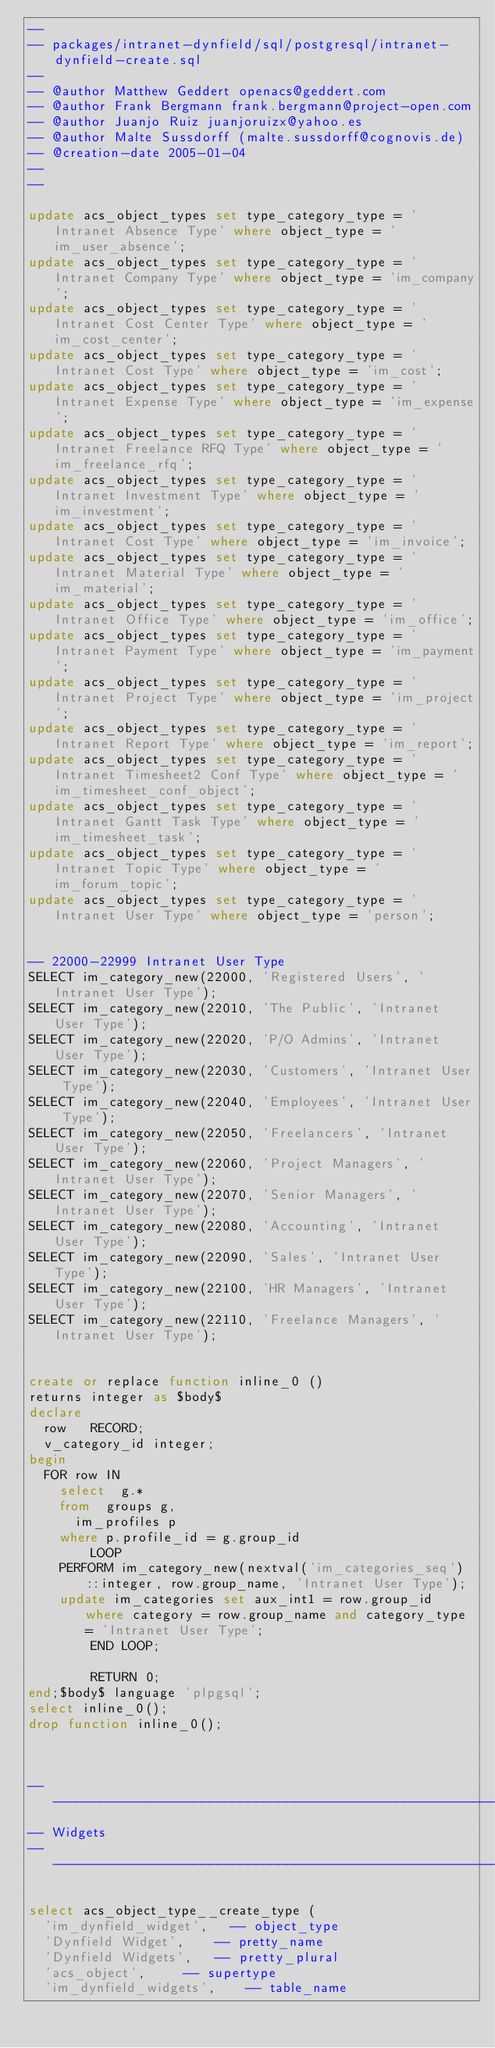<code> <loc_0><loc_0><loc_500><loc_500><_SQL_>--
-- packages/intranet-dynfield/sql/postgresql/intranet-dynfield-create.sql
--
-- @author Matthew Geddert openacs@geddert.com
-- @author Frank Bergmann frank.bergmann@project-open.com
-- @author Juanjo Ruiz juanjoruizx@yahoo.es
-- @author Malte Sussdorff (malte.sussdorff@cognovis.de)
-- @creation-date 2005-01-04
--
--

update acs_object_types set type_category_type = 'Intranet Absence Type' where object_type = 'im_user_absence';
update acs_object_types set type_category_type = 'Intranet Company Type' where object_type = 'im_company';
update acs_object_types set type_category_type = 'Intranet Cost Center Type' where object_type = 'im_cost_center';
update acs_object_types set type_category_type = 'Intranet Cost Type' where object_type = 'im_cost';
update acs_object_types set type_category_type = 'Intranet Expense Type' where object_type = 'im_expense';
update acs_object_types set type_category_type = 'Intranet Freelance RFQ Type' where object_type = 'im_freelance_rfq';
update acs_object_types set type_category_type = 'Intranet Investment Type' where object_type = 'im_investment';
update acs_object_types set type_category_type = 'Intranet Cost Type' where object_type = 'im_invoice';
update acs_object_types set type_category_type = 'Intranet Material Type' where object_type = 'im_material';
update acs_object_types set type_category_type = 'Intranet Office Type' where object_type = 'im_office';
update acs_object_types set type_category_type = 'Intranet Payment Type' where object_type = 'im_payment';
update acs_object_types set type_category_type = 'Intranet Project Type' where object_type = 'im_project';
update acs_object_types set type_category_type = 'Intranet Report Type' where object_type = 'im_report';
update acs_object_types set type_category_type = 'Intranet Timesheet2 Conf Type' where object_type = 'im_timesheet_conf_object';
update acs_object_types set type_category_type = 'Intranet Gantt Task Type' where object_type = 'im_timesheet_task';
update acs_object_types set type_category_type = 'Intranet Topic Type' where object_type = 'im_forum_topic';
update acs_object_types set type_category_type = 'Intranet User Type' where object_type = 'person';


-- 22000-22999 Intranet User Type
SELECT im_category_new(22000, 'Registered Users', 'Intranet User Type');
SELECT im_category_new(22010, 'The Public', 'Intranet User Type');
SELECT im_category_new(22020, 'P/O Admins', 'Intranet User Type');
SELECT im_category_new(22030, 'Customers', 'Intranet User Type');
SELECT im_category_new(22040, 'Employees', 'Intranet User Type');
SELECT im_category_new(22050, 'Freelancers', 'Intranet User Type');
SELECT im_category_new(22060, 'Project Managers', 'Intranet User Type');
SELECT im_category_new(22070, 'Senior Managers', 'Intranet User Type');
SELECT im_category_new(22080, 'Accounting', 'Intranet User Type');
SELECT im_category_new(22090, 'Sales', 'Intranet User Type');
SELECT im_category_new(22100, 'HR Managers', 'Intranet User Type');
SELECT im_category_new(22110, 'Freelance Managers', 'Intranet User Type');


create or replace function inline_0 ()
returns integer as $body$
declare
	row		RECORD;
	v_category_id	integer;
begin
	FOR row IN
		select	g.*
		from	groups g,
			im_profiles p
		where	p.profile_id = g.group_id
        LOOP
		PERFORM im_category_new(nextval('im_categories_seq')::integer, row.group_name, 'Intranet User Type');
		update im_categories set aux_int1 = row.group_id where category = row.group_name and category_type = 'Intranet User Type';
        END LOOP;

        RETURN 0;
end;$body$ language 'plpgsql';
select inline_0();
drop function inline_0();



-- ------------------------------------------------------------------
-- Widgets
-- ------------------------------------------------------------------

select acs_object_type__create_type (
	'im_dynfield_widget',		-- object_type
	'Dynfield Widget',		-- pretty_name
	'Dynfield Widgets',		-- pretty_plural
	'acs_object',			-- supertype
	'im_dynfield_widgets',		-- table_name</code> 